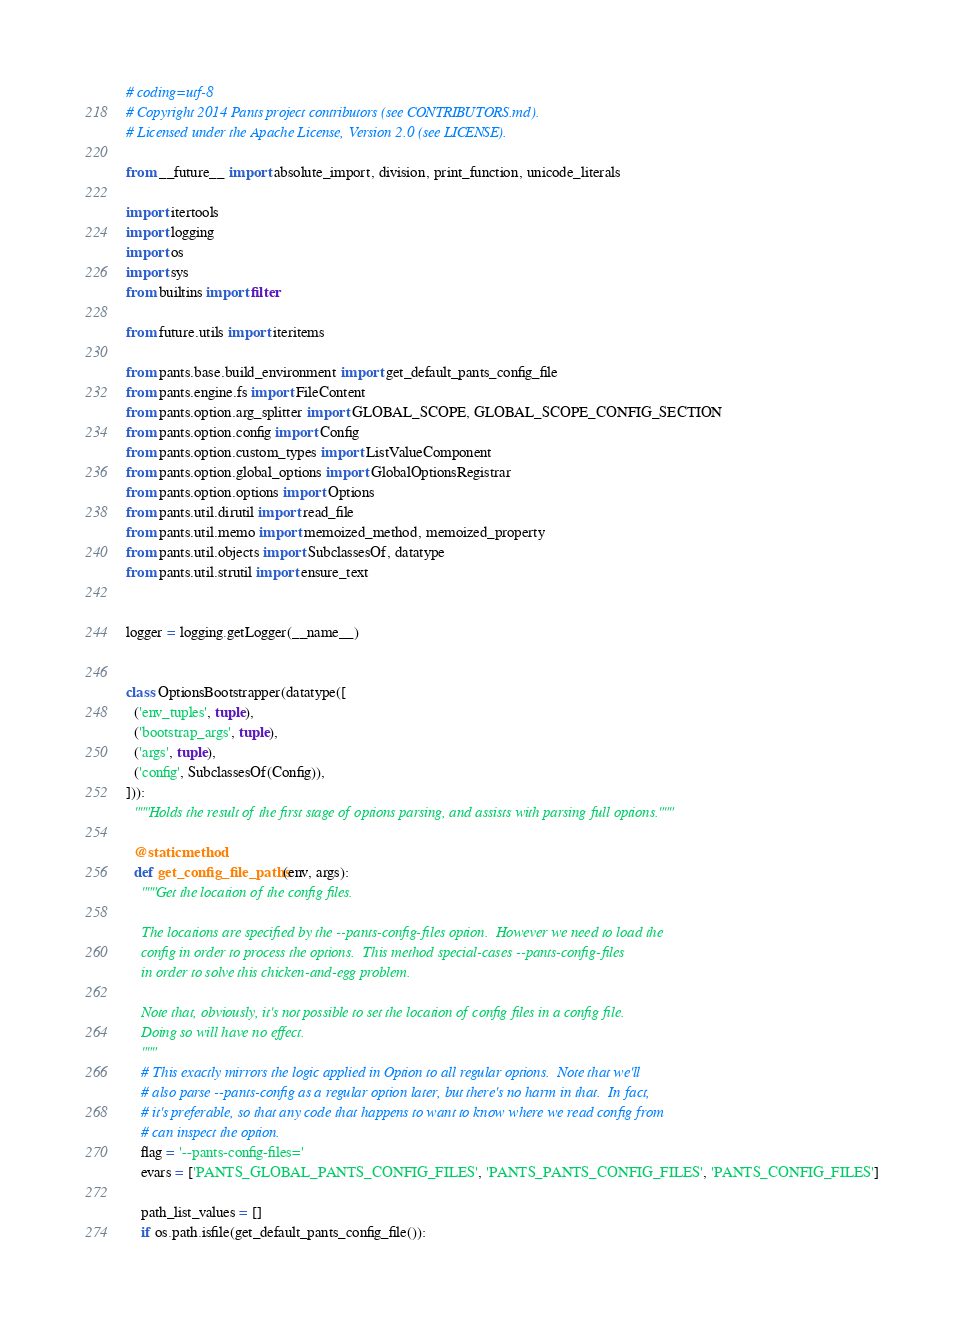<code> <loc_0><loc_0><loc_500><loc_500><_Python_># coding=utf-8
# Copyright 2014 Pants project contributors (see CONTRIBUTORS.md).
# Licensed under the Apache License, Version 2.0 (see LICENSE).

from __future__ import absolute_import, division, print_function, unicode_literals

import itertools
import logging
import os
import sys
from builtins import filter

from future.utils import iteritems

from pants.base.build_environment import get_default_pants_config_file
from pants.engine.fs import FileContent
from pants.option.arg_splitter import GLOBAL_SCOPE, GLOBAL_SCOPE_CONFIG_SECTION
from pants.option.config import Config
from pants.option.custom_types import ListValueComponent
from pants.option.global_options import GlobalOptionsRegistrar
from pants.option.options import Options
from pants.util.dirutil import read_file
from pants.util.memo import memoized_method, memoized_property
from pants.util.objects import SubclassesOf, datatype
from pants.util.strutil import ensure_text


logger = logging.getLogger(__name__)


class OptionsBootstrapper(datatype([
  ('env_tuples', tuple),
  ('bootstrap_args', tuple),
  ('args', tuple),
  ('config', SubclassesOf(Config)),
])):
  """Holds the result of the first stage of options parsing, and assists with parsing full options."""

  @staticmethod
  def get_config_file_paths(env, args):
    """Get the location of the config files.

    The locations are specified by the --pants-config-files option.  However we need to load the
    config in order to process the options.  This method special-cases --pants-config-files
    in order to solve this chicken-and-egg problem.

    Note that, obviously, it's not possible to set the location of config files in a config file.
    Doing so will have no effect.
    """
    # This exactly mirrors the logic applied in Option to all regular options.  Note that we'll
    # also parse --pants-config as a regular option later, but there's no harm in that.  In fact,
    # it's preferable, so that any code that happens to want to know where we read config from
    # can inspect the option.
    flag = '--pants-config-files='
    evars = ['PANTS_GLOBAL_PANTS_CONFIG_FILES', 'PANTS_PANTS_CONFIG_FILES', 'PANTS_CONFIG_FILES']

    path_list_values = []
    if os.path.isfile(get_default_pants_config_file()):</code> 